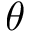<formula> <loc_0><loc_0><loc_500><loc_500>\theta</formula> 